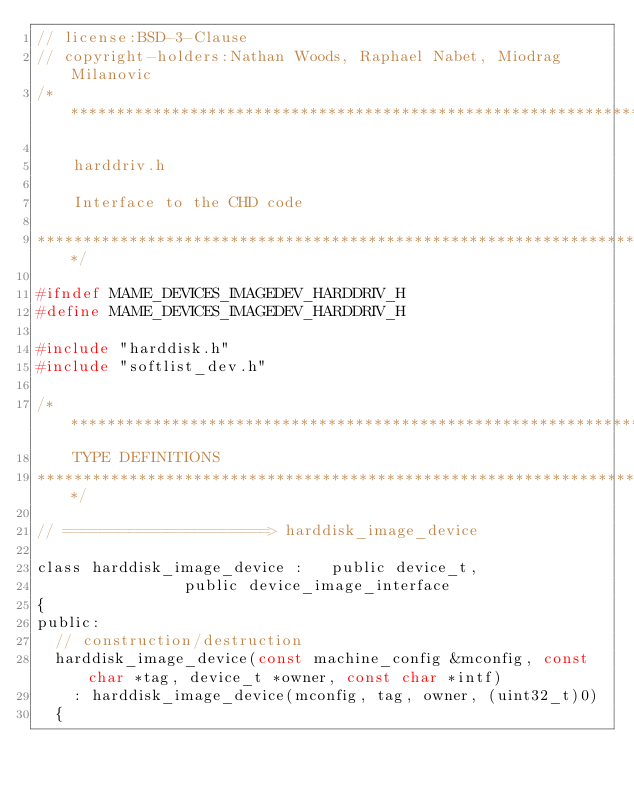Convert code to text. <code><loc_0><loc_0><loc_500><loc_500><_C_>// license:BSD-3-Clause
// copyright-holders:Nathan Woods, Raphael Nabet, Miodrag Milanovic
/*********************************************************************

    harddriv.h

    Interface to the CHD code

*********************************************************************/

#ifndef MAME_DEVICES_IMAGEDEV_HARDDRIV_H
#define MAME_DEVICES_IMAGEDEV_HARDDRIV_H

#include "harddisk.h"
#include "softlist_dev.h"

/***************************************************************************
    TYPE DEFINITIONS
***************************************************************************/

// ======================> harddisk_image_device

class harddisk_image_device :   public device_t,
								public device_image_interface
{
public:
	// construction/destruction
	harddisk_image_device(const machine_config &mconfig, const char *tag, device_t *owner, const char *intf)
		: harddisk_image_device(mconfig, tag, owner, (uint32_t)0)
	{</code> 